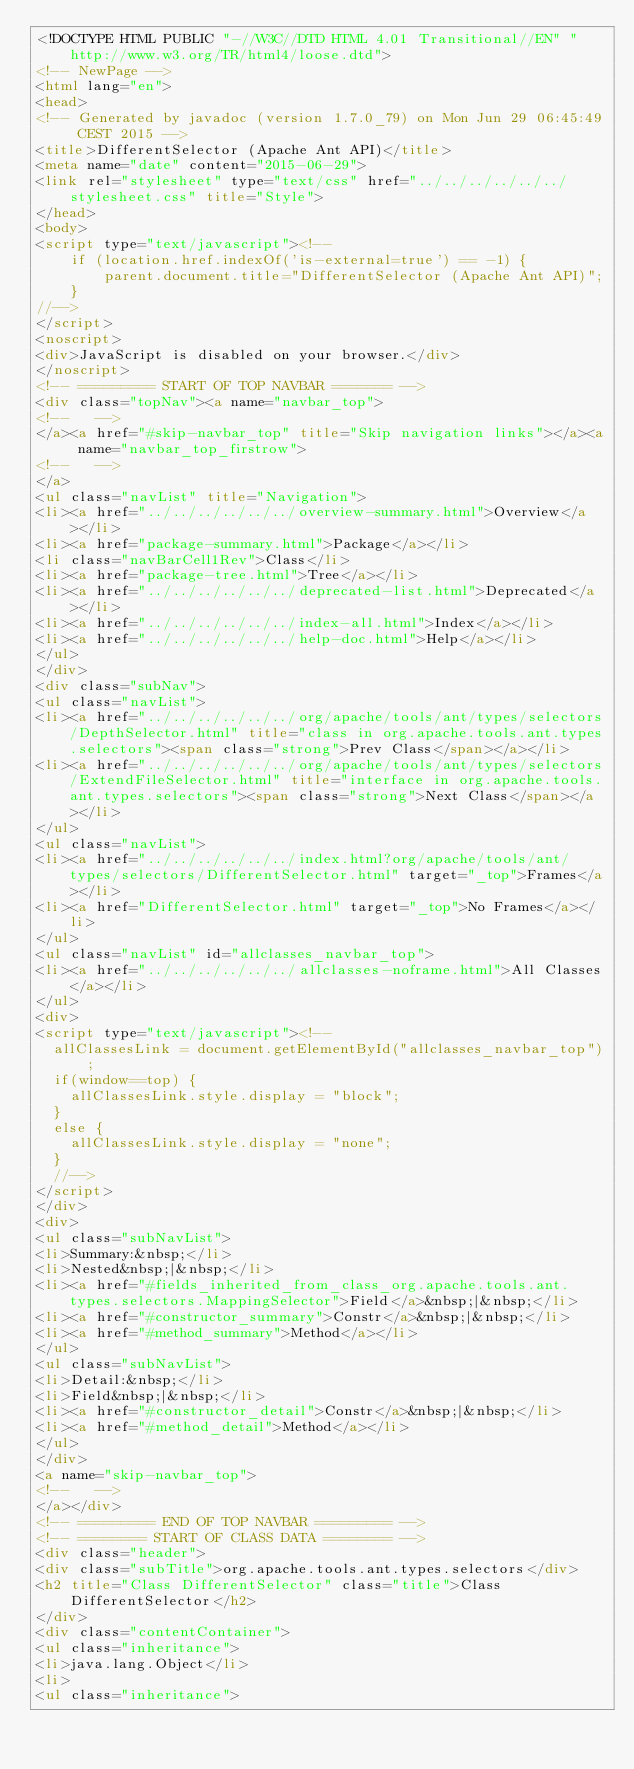Convert code to text. <code><loc_0><loc_0><loc_500><loc_500><_HTML_><!DOCTYPE HTML PUBLIC "-//W3C//DTD HTML 4.01 Transitional//EN" "http://www.w3.org/TR/html4/loose.dtd">
<!-- NewPage -->
<html lang="en">
<head>
<!-- Generated by javadoc (version 1.7.0_79) on Mon Jun 29 06:45:49 CEST 2015 -->
<title>DifferentSelector (Apache Ant API)</title>
<meta name="date" content="2015-06-29">
<link rel="stylesheet" type="text/css" href="../../../../../../stylesheet.css" title="Style">
</head>
<body>
<script type="text/javascript"><!--
    if (location.href.indexOf('is-external=true') == -1) {
        parent.document.title="DifferentSelector (Apache Ant API)";
    }
//-->
</script>
<noscript>
<div>JavaScript is disabled on your browser.</div>
</noscript>
<!-- ========= START OF TOP NAVBAR ======= -->
<div class="topNav"><a name="navbar_top">
<!--   -->
</a><a href="#skip-navbar_top" title="Skip navigation links"></a><a name="navbar_top_firstrow">
<!--   -->
</a>
<ul class="navList" title="Navigation">
<li><a href="../../../../../../overview-summary.html">Overview</a></li>
<li><a href="package-summary.html">Package</a></li>
<li class="navBarCell1Rev">Class</li>
<li><a href="package-tree.html">Tree</a></li>
<li><a href="../../../../../../deprecated-list.html">Deprecated</a></li>
<li><a href="../../../../../../index-all.html">Index</a></li>
<li><a href="../../../../../../help-doc.html">Help</a></li>
</ul>
</div>
<div class="subNav">
<ul class="navList">
<li><a href="../../../../../../org/apache/tools/ant/types/selectors/DepthSelector.html" title="class in org.apache.tools.ant.types.selectors"><span class="strong">Prev Class</span></a></li>
<li><a href="../../../../../../org/apache/tools/ant/types/selectors/ExtendFileSelector.html" title="interface in org.apache.tools.ant.types.selectors"><span class="strong">Next Class</span></a></li>
</ul>
<ul class="navList">
<li><a href="../../../../../../index.html?org/apache/tools/ant/types/selectors/DifferentSelector.html" target="_top">Frames</a></li>
<li><a href="DifferentSelector.html" target="_top">No Frames</a></li>
</ul>
<ul class="navList" id="allclasses_navbar_top">
<li><a href="../../../../../../allclasses-noframe.html">All Classes</a></li>
</ul>
<div>
<script type="text/javascript"><!--
  allClassesLink = document.getElementById("allclasses_navbar_top");
  if(window==top) {
    allClassesLink.style.display = "block";
  }
  else {
    allClassesLink.style.display = "none";
  }
  //-->
</script>
</div>
<div>
<ul class="subNavList">
<li>Summary:&nbsp;</li>
<li>Nested&nbsp;|&nbsp;</li>
<li><a href="#fields_inherited_from_class_org.apache.tools.ant.types.selectors.MappingSelector">Field</a>&nbsp;|&nbsp;</li>
<li><a href="#constructor_summary">Constr</a>&nbsp;|&nbsp;</li>
<li><a href="#method_summary">Method</a></li>
</ul>
<ul class="subNavList">
<li>Detail:&nbsp;</li>
<li>Field&nbsp;|&nbsp;</li>
<li><a href="#constructor_detail">Constr</a>&nbsp;|&nbsp;</li>
<li><a href="#method_detail">Method</a></li>
</ul>
</div>
<a name="skip-navbar_top">
<!--   -->
</a></div>
<!-- ========= END OF TOP NAVBAR ========= -->
<!-- ======== START OF CLASS DATA ======== -->
<div class="header">
<div class="subTitle">org.apache.tools.ant.types.selectors</div>
<h2 title="Class DifferentSelector" class="title">Class DifferentSelector</h2>
</div>
<div class="contentContainer">
<ul class="inheritance">
<li>java.lang.Object</li>
<li>
<ul class="inheritance"></code> 